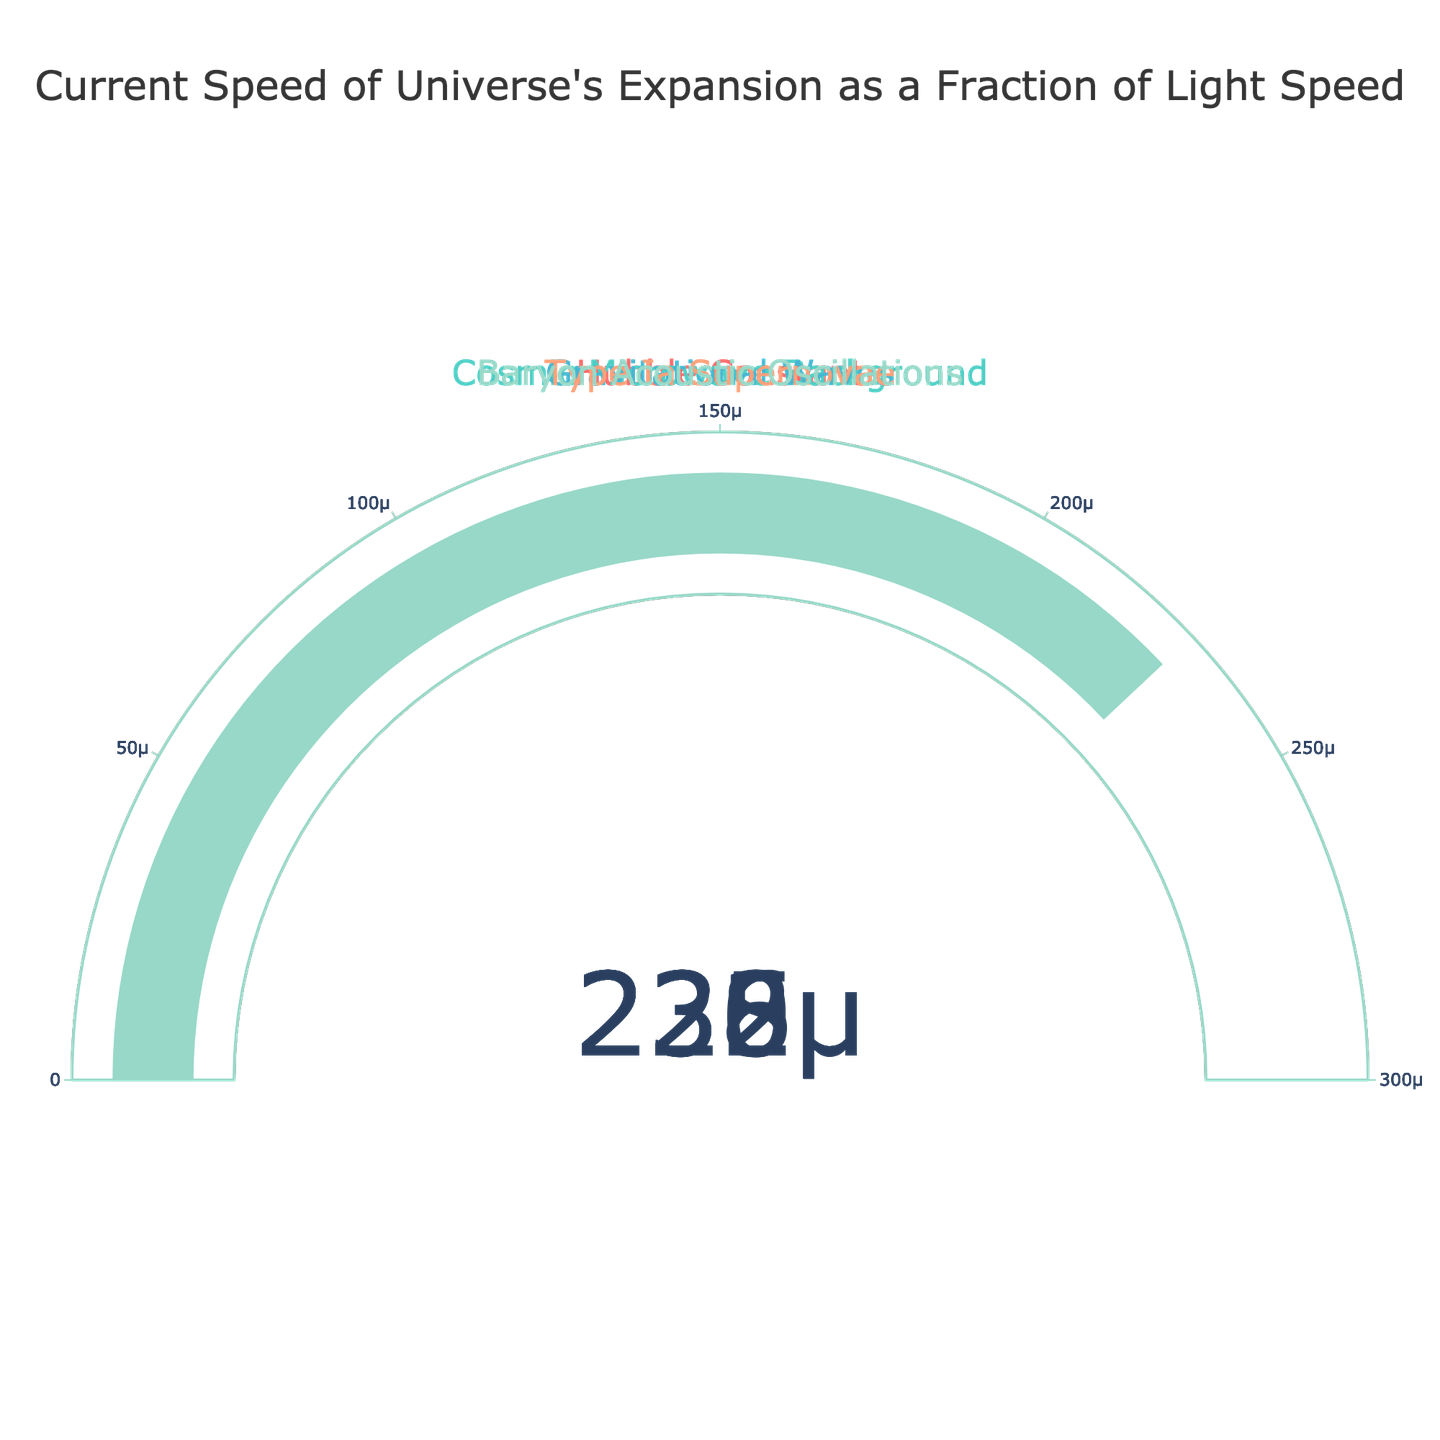What is the title of the figure? The figure's title is typically located at the top and provides a summary of what the figure represents.
Answer: Current Speed of Universe's Expansion as a Fraction of Light Speed How many data points are represented in the figure? Each gauge corresponds to a data point, and there are five different gauges in the figure.
Answer: 5 What is the highest value displayed on the gauges? By comparing all the gauge values, the highest one is found under the "Gravitational Waves" category.
Answer: 0.000235 Which expansion rate has the lowest value on its gauge? By observing all the gauges, the "Cosmic Microwave Background" gauge has the lowest value.
Answer: Cosmic Microwave Background What is the range of the gauge axes? For each gauge, the axis range is annotated, showing a minimum value of 0 and a maximum value of 0.0003.
Answer: 0 to 0.0003 Calculate the average value of all the gauge readings. Sum all gauge values (0.000232 + 0.000226 + 0.000235 + 0.000230 + 0.000228) and divide by the number of gauges (5). The sum is 0.001151, so the average is 0.001151 / 5.
Answer: 0.0002302 Which two expansion rates have the smallest difference between their values? By calculating the absolute differences between each combination of gauge values, "Hubble Constant" (0.000232) and "Type Ia Supernovae" (0.000230) have the smallest difference.
Answer: Hubble Constant and Type Ia Supernovae What color is used for the "Baryon Acoustic Oscillations" gauge bar? Observing the gauge bar for "Baryon Acoustic Oscillations," we see it is colored in light blue or aqua.
Answer: Light blue (aqua) Are any of the gauge bars colored in red? Checking all the gauges for the color red, we see that “Hubble Constant” has a red-colored gauge bar.
Answer: Yes How much greater is the "Gravitational Waves" value compared to the "Cosmic Microwave Background" value? Subtract the "Cosmic Microwave Background" value (0.000226) from the "Gravitational Waves" value (0.000235). The difference is 0.000235 - 0.000226.
Answer: 0.000009 